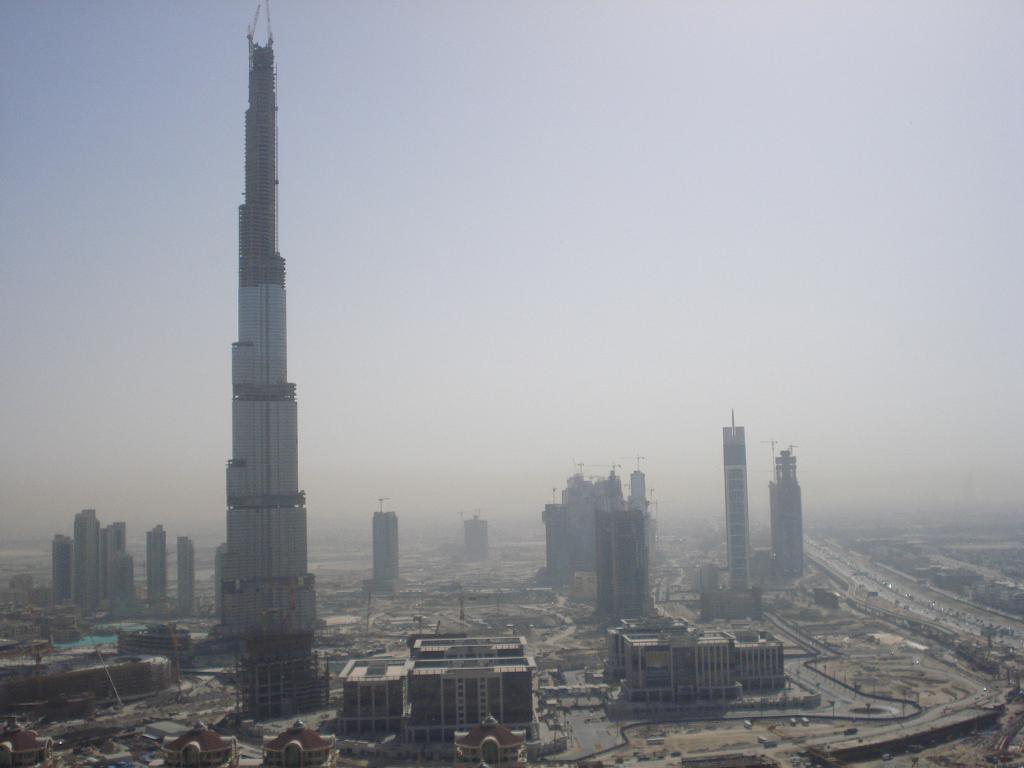What type of location is shown in the image? The image depicts a well-developed city. What can be seen in the city? There are many buildings and huge towers in the city. How are the roads in the city? The roads in the city are very wide and long. What is the city attempting to do in the image? The image does not depict the city attempting to do anything; it simply shows the city's appearance. 